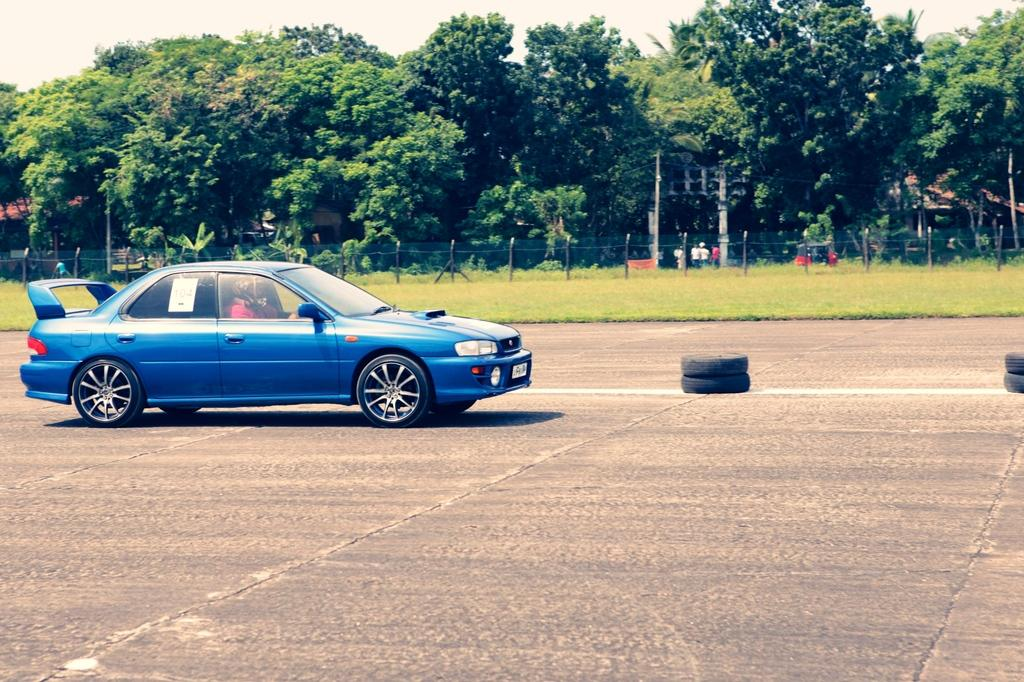What is the main subject of the image? There is a person in a car in the image. What can be seen on the road in the image? There are tires visible on the road. What type of vegetation is present in the image? There are trees and plants in the image. What type of barrier is visible in the image? There is fencing in the image. Are there any other people in the image besides the person in the car? Yes, there are other people in the image. What type of wave can be seen crashing on the shore in the image? There is no wave or shore present in the image; it features a person in a car, trees, plants, fencing, and other people. 